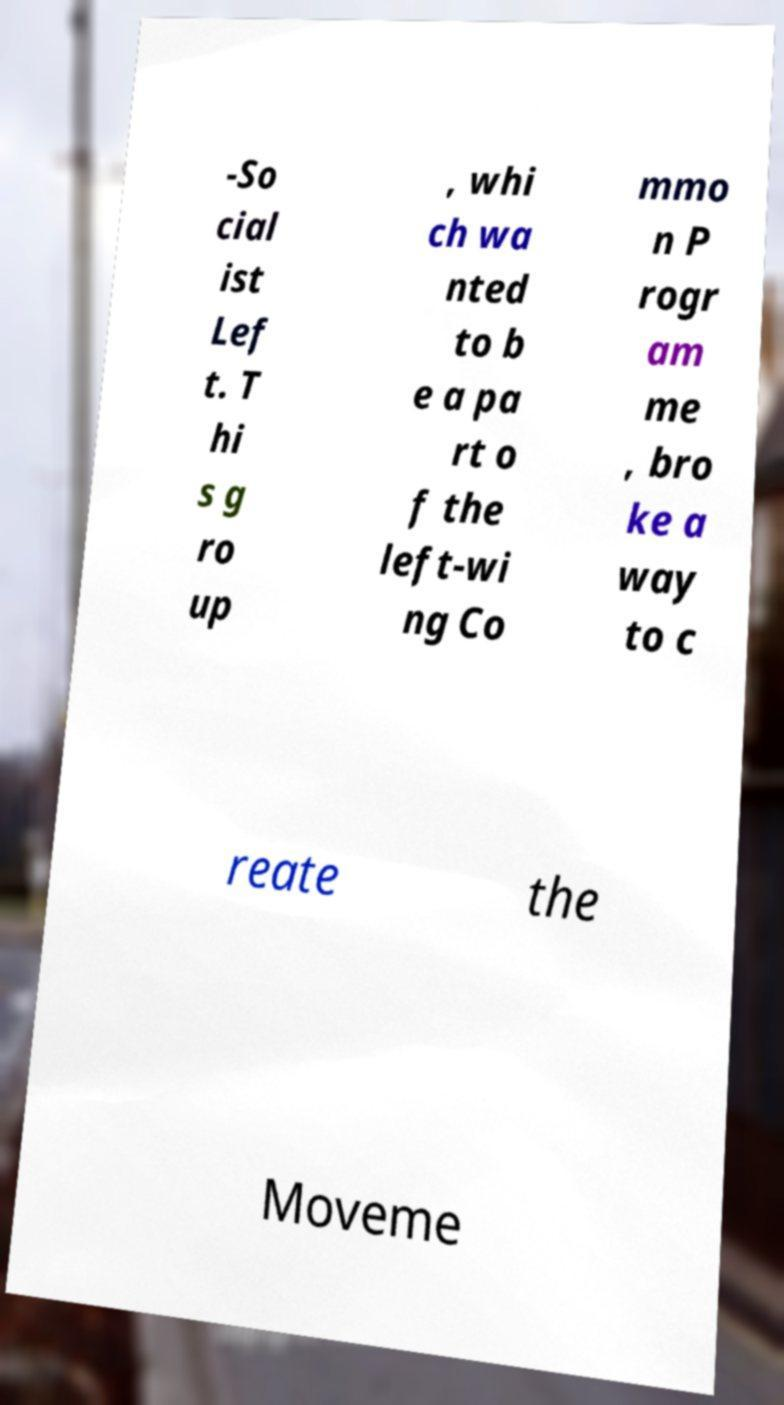Can you accurately transcribe the text from the provided image for me? -So cial ist Lef t. T hi s g ro up , whi ch wa nted to b e a pa rt o f the left-wi ng Co mmo n P rogr am me , bro ke a way to c reate the Moveme 